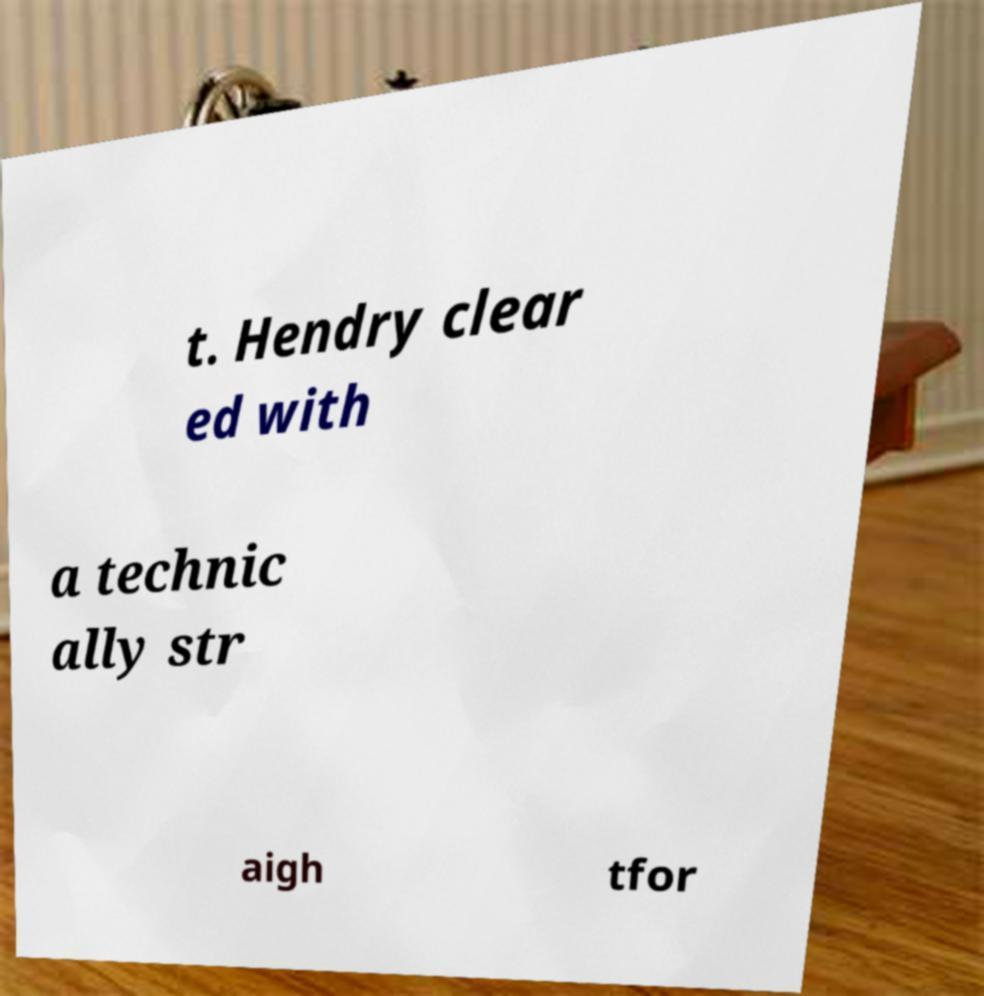Could you extract and type out the text from this image? t. Hendry clear ed with a technic ally str aigh tfor 